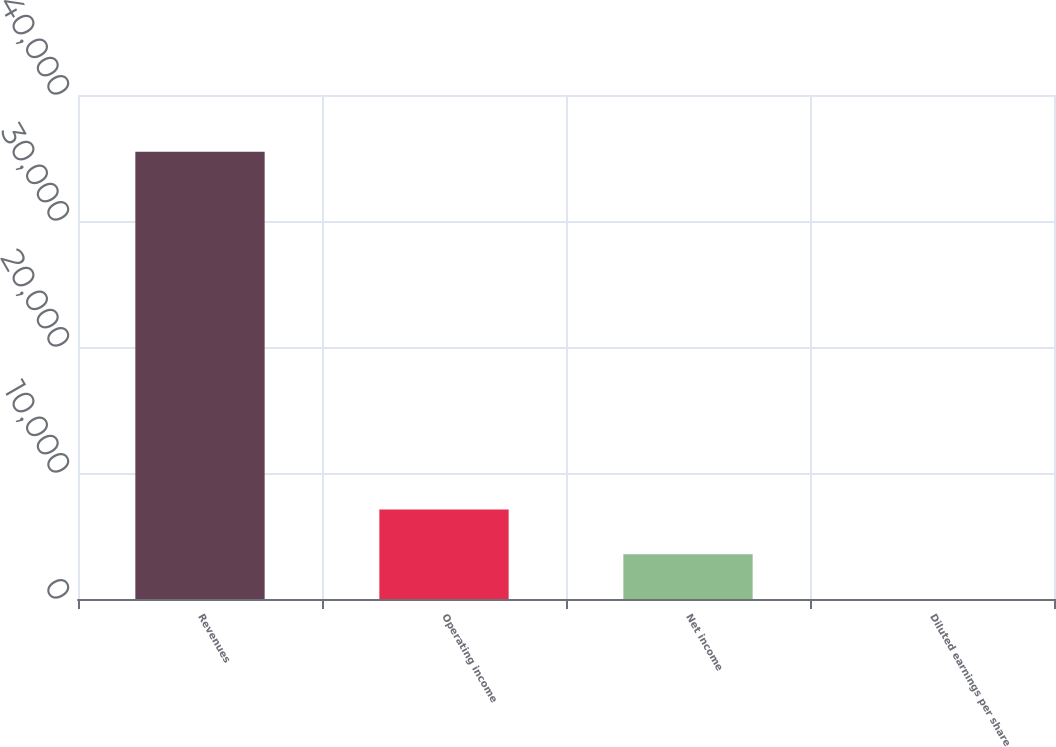Convert chart to OTSL. <chart><loc_0><loc_0><loc_500><loc_500><bar_chart><fcel>Revenues<fcel>Operating income<fcel>Net income<fcel>Diluted earnings per share<nl><fcel>35497<fcel>7099.65<fcel>3549.98<fcel>0.31<nl></chart> 